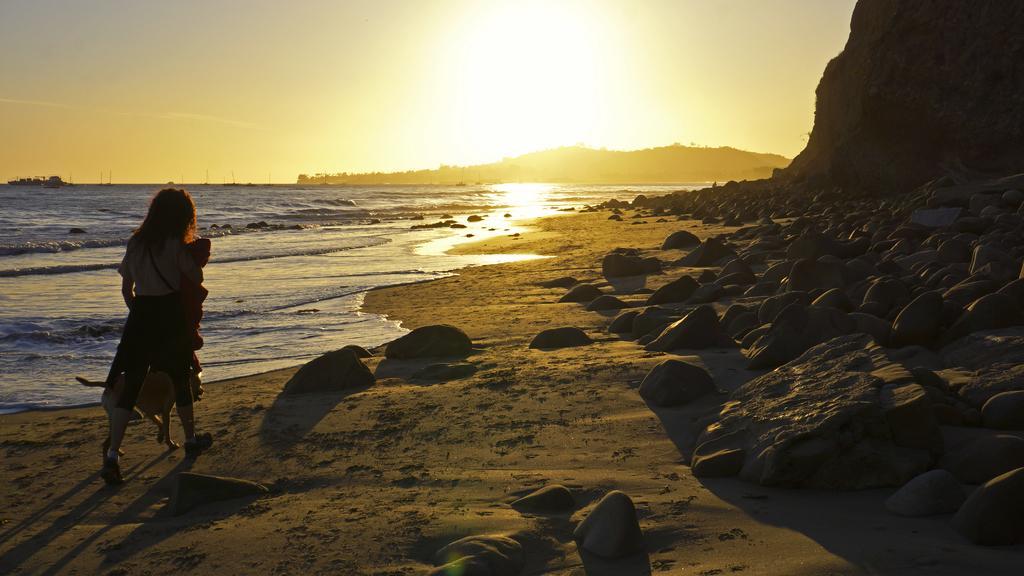Please provide a concise description of this image. There is a lady, dog and stones in the foreground area of the image, there are stones, poles, beach, it seems like mountains and the sky in the background. 